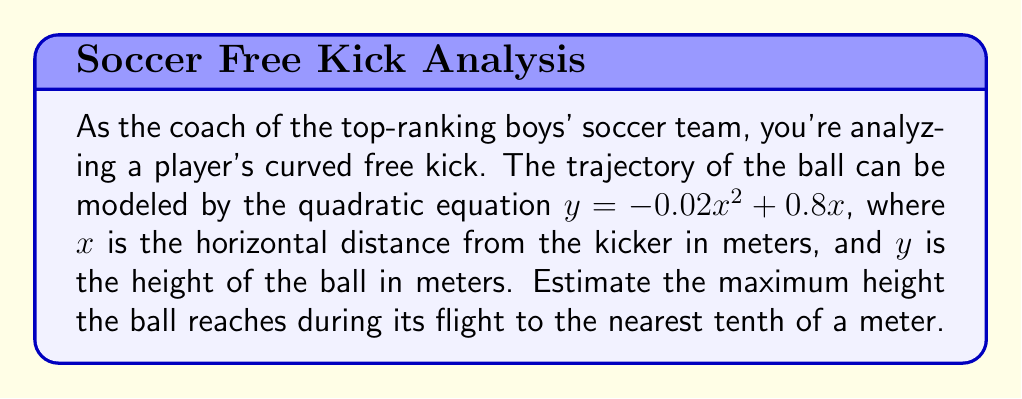Can you solve this math problem? To find the maximum height of the ball, we need to follow these steps:

1) The quadratic equation is in the form $y = ax^2 + bx + c$, where:
   $a = -0.02$
   $b = 0.8$
   $c = 0$

2) For a quadratic function, the x-coordinate of the vertex (which corresponds to the maximum height for this parabola) is given by the formula:

   $$x = -\frac{b}{2a}$$

3) Substituting our values:

   $$x = -\frac{0.8}{2(-0.02)} = -\frac{0.8}{-0.04} = 20$$

4) To find the maximum height, we need to substitute this x-value back into our original equation:

   $$y = -0.02(20)^2 + 0.8(20)$$

5) Simplifying:
   $$y = -0.02(400) + 16$$
   $$y = -8 + 16 = 8$$

Therefore, the maximum height the ball reaches is 8 meters.
Answer: 8.0 meters 